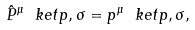Convert formula to latex. <formula><loc_0><loc_0><loc_500><loc_500>\hat { P } ^ { \mu } \ k e t { p , \sigma } = p ^ { \mu } \ k e t { p , \sigma } ,</formula> 